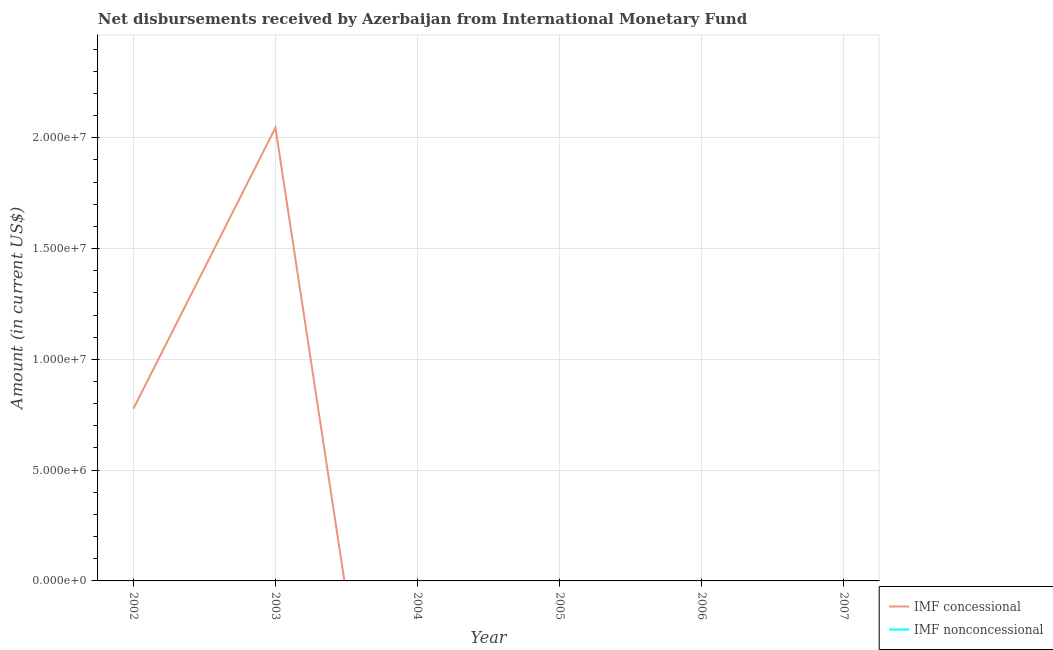Does the line corresponding to net non concessional disbursements from imf intersect with the line corresponding to net concessional disbursements from imf?
Ensure brevity in your answer.  Yes. Is the number of lines equal to the number of legend labels?
Keep it short and to the point. No. Across all years, what is the maximum net concessional disbursements from imf?
Make the answer very short. 2.05e+07. Across all years, what is the minimum net non concessional disbursements from imf?
Offer a very short reply. 0. In which year was the net concessional disbursements from imf maximum?
Your response must be concise. 2003. What is the total net concessional disbursements from imf in the graph?
Ensure brevity in your answer.  2.82e+07. What is the difference between the net non concessional disbursements from imf in 2005 and the net concessional disbursements from imf in 2004?
Ensure brevity in your answer.  0. What is the average net non concessional disbursements from imf per year?
Make the answer very short. 0. In how many years, is the net concessional disbursements from imf greater than 10000000 US$?
Make the answer very short. 1. What is the ratio of the net concessional disbursements from imf in 2002 to that in 2003?
Your answer should be compact. 0.38. What is the difference between the highest and the lowest net concessional disbursements from imf?
Ensure brevity in your answer.  2.05e+07. Is the net concessional disbursements from imf strictly less than the net non concessional disbursements from imf over the years?
Offer a terse response. No. What is the difference between two consecutive major ticks on the Y-axis?
Give a very brief answer. 5.00e+06. Are the values on the major ticks of Y-axis written in scientific E-notation?
Your response must be concise. Yes. Does the graph contain any zero values?
Provide a succinct answer. Yes. How are the legend labels stacked?
Offer a terse response. Vertical. What is the title of the graph?
Keep it short and to the point. Net disbursements received by Azerbaijan from International Monetary Fund. What is the label or title of the X-axis?
Provide a short and direct response. Year. What is the Amount (in current US$) in IMF concessional in 2002?
Your response must be concise. 7.77e+06. What is the Amount (in current US$) of IMF nonconcessional in 2002?
Keep it short and to the point. 0. What is the Amount (in current US$) of IMF concessional in 2003?
Ensure brevity in your answer.  2.05e+07. What is the Amount (in current US$) in IMF concessional in 2004?
Your answer should be compact. 0. What is the Amount (in current US$) in IMF nonconcessional in 2004?
Your answer should be very brief. 0. What is the Amount (in current US$) in IMF concessional in 2005?
Make the answer very short. 0. What is the Amount (in current US$) in IMF nonconcessional in 2006?
Make the answer very short. 0. What is the Amount (in current US$) in IMF concessional in 2007?
Offer a very short reply. 0. Across all years, what is the maximum Amount (in current US$) of IMF concessional?
Offer a very short reply. 2.05e+07. Across all years, what is the minimum Amount (in current US$) in IMF concessional?
Offer a very short reply. 0. What is the total Amount (in current US$) in IMF concessional in the graph?
Provide a succinct answer. 2.82e+07. What is the difference between the Amount (in current US$) of IMF concessional in 2002 and that in 2003?
Your answer should be very brief. -1.27e+07. What is the average Amount (in current US$) of IMF concessional per year?
Your response must be concise. 4.70e+06. What is the ratio of the Amount (in current US$) in IMF concessional in 2002 to that in 2003?
Ensure brevity in your answer.  0.38. What is the difference between the highest and the lowest Amount (in current US$) in IMF concessional?
Your answer should be very brief. 2.05e+07. 